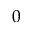<formula> <loc_0><loc_0><loc_500><loc_500>0</formula> 